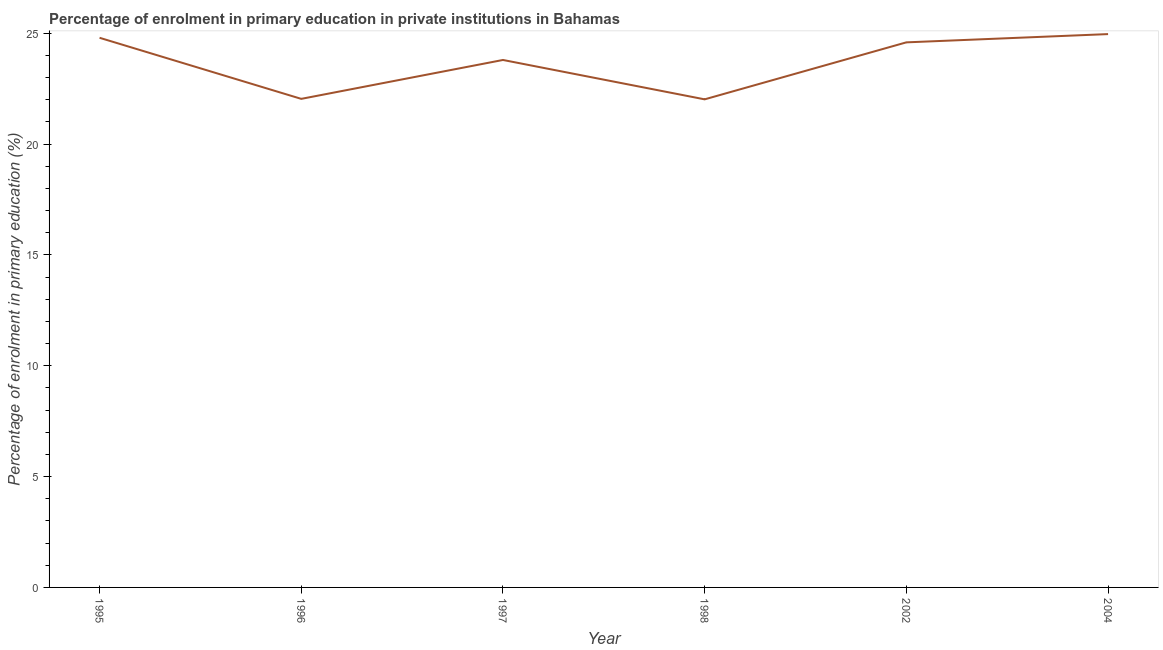What is the enrolment percentage in primary education in 1996?
Ensure brevity in your answer.  22.04. Across all years, what is the maximum enrolment percentage in primary education?
Ensure brevity in your answer.  24.97. Across all years, what is the minimum enrolment percentage in primary education?
Your answer should be very brief. 22.02. In which year was the enrolment percentage in primary education maximum?
Keep it short and to the point. 2004. In which year was the enrolment percentage in primary education minimum?
Your answer should be compact. 1998. What is the sum of the enrolment percentage in primary education?
Your response must be concise. 142.22. What is the difference between the enrolment percentage in primary education in 1996 and 2002?
Provide a short and direct response. -2.55. What is the average enrolment percentage in primary education per year?
Your answer should be compact. 23.7. What is the median enrolment percentage in primary education?
Give a very brief answer. 24.19. In how many years, is the enrolment percentage in primary education greater than 20 %?
Your response must be concise. 6. What is the ratio of the enrolment percentage in primary education in 1995 to that in 2004?
Your answer should be compact. 0.99. Is the difference between the enrolment percentage in primary education in 2002 and 2004 greater than the difference between any two years?
Provide a short and direct response. No. What is the difference between the highest and the second highest enrolment percentage in primary education?
Ensure brevity in your answer.  0.17. Is the sum of the enrolment percentage in primary education in 1995 and 2002 greater than the maximum enrolment percentage in primary education across all years?
Provide a short and direct response. Yes. What is the difference between the highest and the lowest enrolment percentage in primary education?
Ensure brevity in your answer.  2.94. In how many years, is the enrolment percentage in primary education greater than the average enrolment percentage in primary education taken over all years?
Give a very brief answer. 4. Does the enrolment percentage in primary education monotonically increase over the years?
Give a very brief answer. No. How many years are there in the graph?
Keep it short and to the point. 6. What is the difference between two consecutive major ticks on the Y-axis?
Offer a terse response. 5. Are the values on the major ticks of Y-axis written in scientific E-notation?
Your answer should be very brief. No. Does the graph contain any zero values?
Keep it short and to the point. No. What is the title of the graph?
Ensure brevity in your answer.  Percentage of enrolment in primary education in private institutions in Bahamas. What is the label or title of the Y-axis?
Ensure brevity in your answer.  Percentage of enrolment in primary education (%). What is the Percentage of enrolment in primary education (%) of 1995?
Ensure brevity in your answer.  24.8. What is the Percentage of enrolment in primary education (%) in 1996?
Offer a very short reply. 22.04. What is the Percentage of enrolment in primary education (%) in 1997?
Keep it short and to the point. 23.8. What is the Percentage of enrolment in primary education (%) in 1998?
Ensure brevity in your answer.  22.02. What is the Percentage of enrolment in primary education (%) in 2002?
Your answer should be very brief. 24.59. What is the Percentage of enrolment in primary education (%) in 2004?
Your response must be concise. 24.97. What is the difference between the Percentage of enrolment in primary education (%) in 1995 and 1996?
Ensure brevity in your answer.  2.76. What is the difference between the Percentage of enrolment in primary education (%) in 1995 and 1997?
Give a very brief answer. 1. What is the difference between the Percentage of enrolment in primary education (%) in 1995 and 1998?
Give a very brief answer. 2.78. What is the difference between the Percentage of enrolment in primary education (%) in 1995 and 2002?
Your response must be concise. 0.21. What is the difference between the Percentage of enrolment in primary education (%) in 1995 and 2004?
Ensure brevity in your answer.  -0.17. What is the difference between the Percentage of enrolment in primary education (%) in 1996 and 1997?
Give a very brief answer. -1.75. What is the difference between the Percentage of enrolment in primary education (%) in 1996 and 1998?
Your response must be concise. 0.02. What is the difference between the Percentage of enrolment in primary education (%) in 1996 and 2002?
Give a very brief answer. -2.55. What is the difference between the Percentage of enrolment in primary education (%) in 1996 and 2004?
Your answer should be compact. -2.92. What is the difference between the Percentage of enrolment in primary education (%) in 1997 and 1998?
Your answer should be very brief. 1.78. What is the difference between the Percentage of enrolment in primary education (%) in 1997 and 2002?
Ensure brevity in your answer.  -0.79. What is the difference between the Percentage of enrolment in primary education (%) in 1997 and 2004?
Provide a succinct answer. -1.17. What is the difference between the Percentage of enrolment in primary education (%) in 1998 and 2002?
Your response must be concise. -2.57. What is the difference between the Percentage of enrolment in primary education (%) in 1998 and 2004?
Make the answer very short. -2.94. What is the difference between the Percentage of enrolment in primary education (%) in 2002 and 2004?
Ensure brevity in your answer.  -0.37. What is the ratio of the Percentage of enrolment in primary education (%) in 1995 to that in 1996?
Offer a terse response. 1.12. What is the ratio of the Percentage of enrolment in primary education (%) in 1995 to that in 1997?
Make the answer very short. 1.04. What is the ratio of the Percentage of enrolment in primary education (%) in 1995 to that in 1998?
Provide a succinct answer. 1.13. What is the ratio of the Percentage of enrolment in primary education (%) in 1995 to that in 2004?
Ensure brevity in your answer.  0.99. What is the ratio of the Percentage of enrolment in primary education (%) in 1996 to that in 1997?
Offer a very short reply. 0.93. What is the ratio of the Percentage of enrolment in primary education (%) in 1996 to that in 2002?
Your answer should be compact. 0.9. What is the ratio of the Percentage of enrolment in primary education (%) in 1996 to that in 2004?
Your response must be concise. 0.88. What is the ratio of the Percentage of enrolment in primary education (%) in 1997 to that in 1998?
Your response must be concise. 1.08. What is the ratio of the Percentage of enrolment in primary education (%) in 1997 to that in 2002?
Make the answer very short. 0.97. What is the ratio of the Percentage of enrolment in primary education (%) in 1997 to that in 2004?
Offer a very short reply. 0.95. What is the ratio of the Percentage of enrolment in primary education (%) in 1998 to that in 2002?
Offer a terse response. 0.9. What is the ratio of the Percentage of enrolment in primary education (%) in 1998 to that in 2004?
Offer a very short reply. 0.88. 